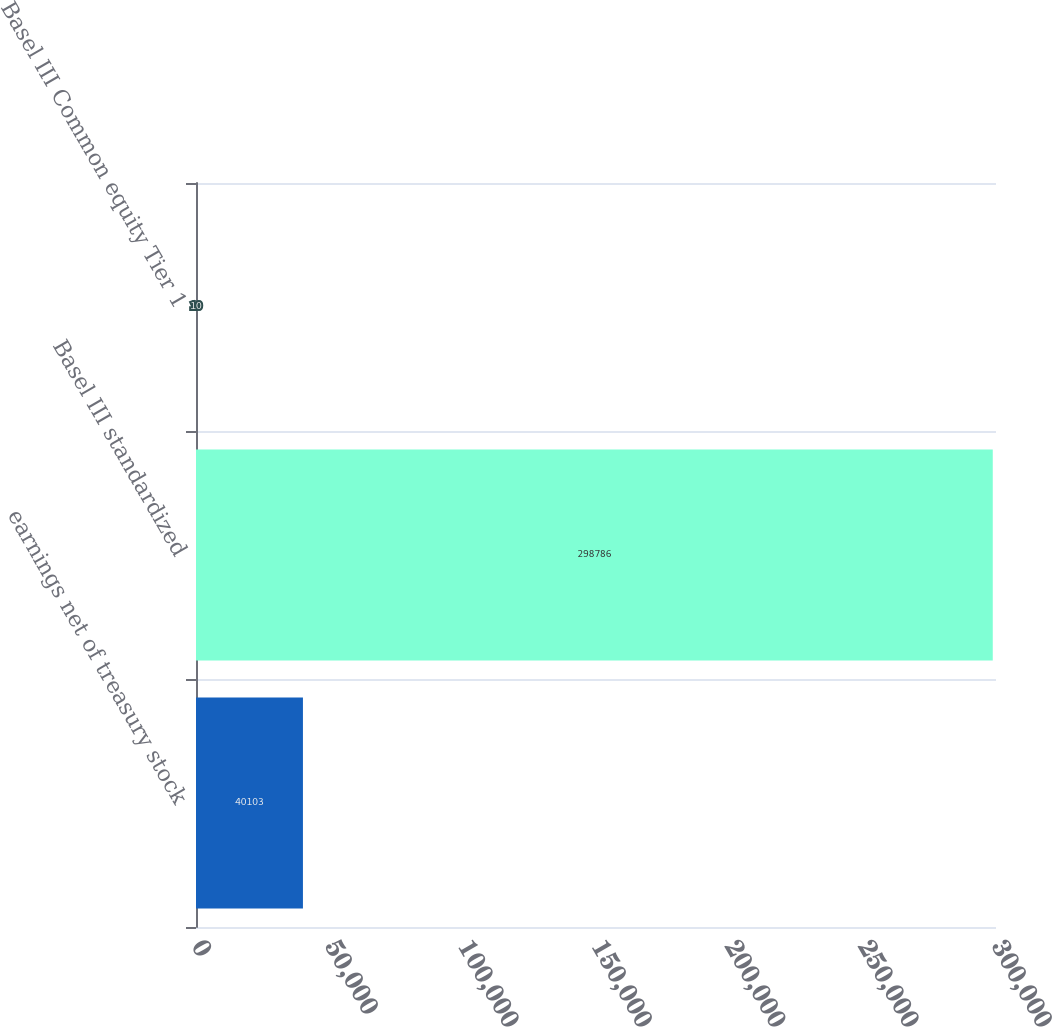Convert chart to OTSL. <chart><loc_0><loc_0><loc_500><loc_500><bar_chart><fcel>earnings net of treasury stock<fcel>Basel III standardized<fcel>Basel III Common equity Tier 1<nl><fcel>40103<fcel>298786<fcel>10<nl></chart> 